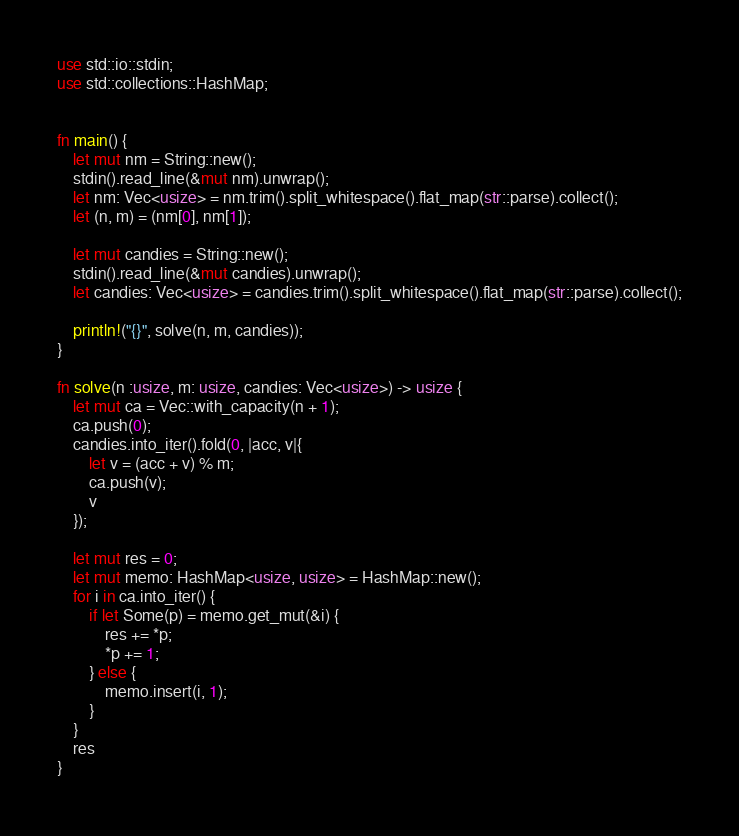<code> <loc_0><loc_0><loc_500><loc_500><_Rust_>use std::io::stdin;
use std::collections::HashMap;


fn main() {
    let mut nm = String::new();
    stdin().read_line(&mut nm).unwrap();
    let nm: Vec<usize> = nm.trim().split_whitespace().flat_map(str::parse).collect();
    let (n, m) = (nm[0], nm[1]);

    let mut candies = String::new();
    stdin().read_line(&mut candies).unwrap();
    let candies: Vec<usize> = candies.trim().split_whitespace().flat_map(str::parse).collect();

    println!("{}", solve(n, m, candies));
}

fn solve(n :usize, m: usize, candies: Vec<usize>) -> usize {
    let mut ca = Vec::with_capacity(n + 1);
    ca.push(0);
    candies.into_iter().fold(0, |acc, v|{
        let v = (acc + v) % m;
        ca.push(v);
        v
    });

    let mut res = 0;
    let mut memo: HashMap<usize, usize> = HashMap::new();
    for i in ca.into_iter() {
        if let Some(p) = memo.get_mut(&i) {
            res += *p;
            *p += 1;
        } else {
            memo.insert(i, 1);
        }
    }
    res
}
</code> 